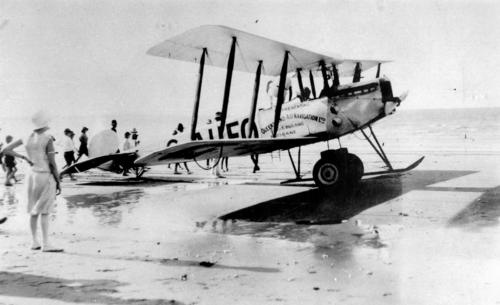Describe the objects in this image and their specific colors. I can see airplane in lightgray, black, darkgray, and gray tones, people in lightgray, darkgray, gray, and black tones, people in lightgray, black, darkgray, and gray tones, people in lightgray, black, darkgray, and gray tones, and people in lightgray, gray, black, and darkgray tones in this image. 